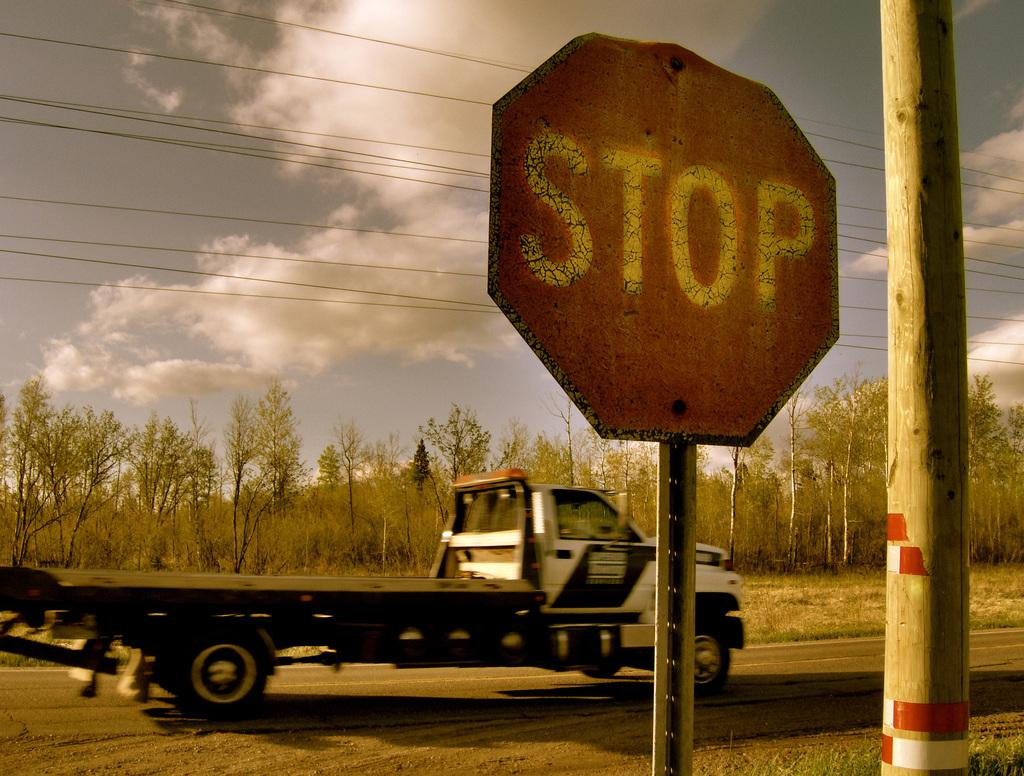<image>
Create a compact narrative representing the image presented. a tractor trailor parked behind a red stop sign 